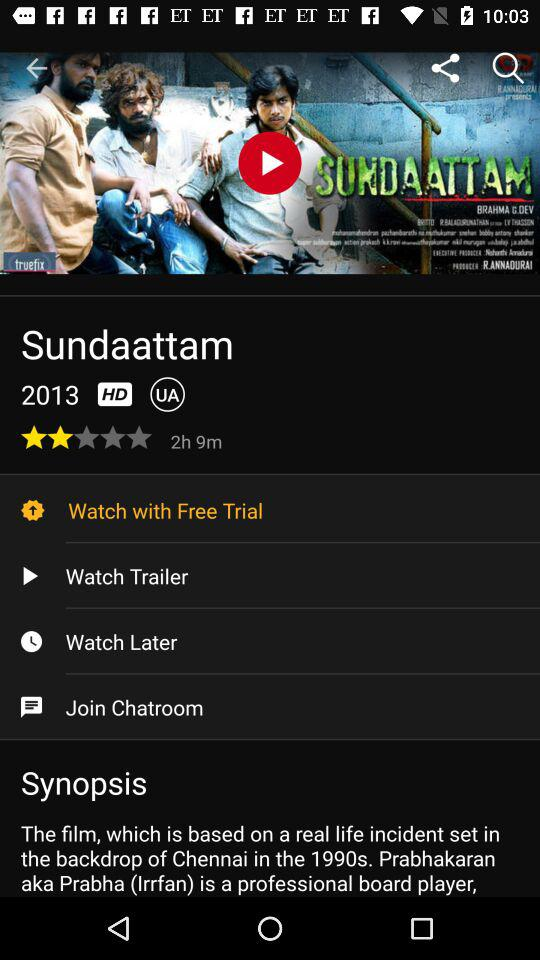In what year was the movie released? The movie was released in 2013. 